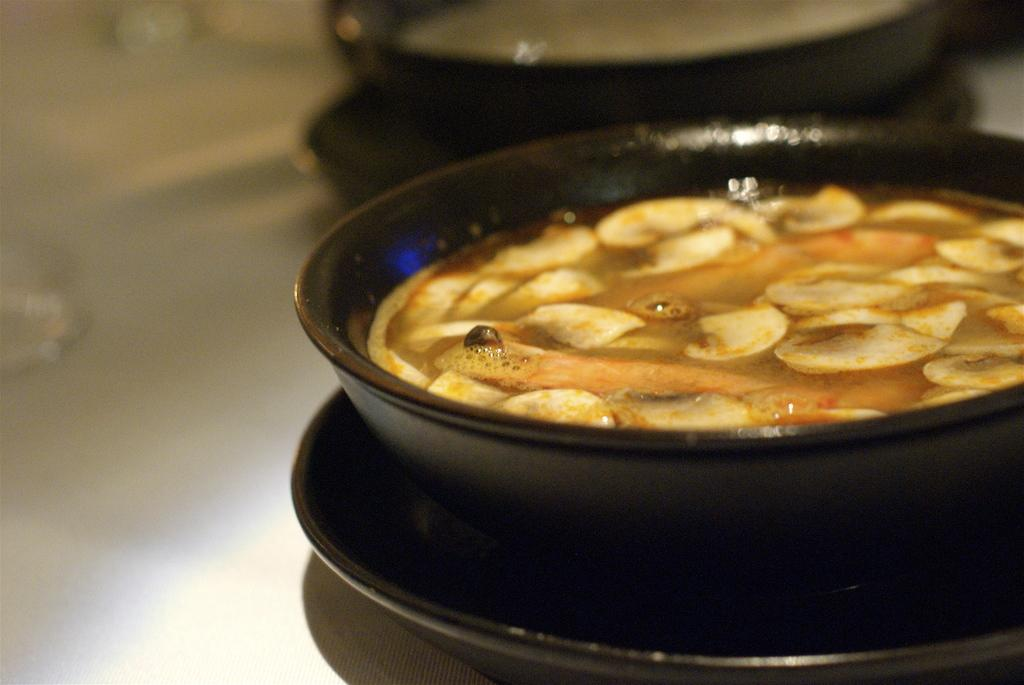What type of objects can be seen in the image? There are food items in the image. In what type of container are the food items placed? The food items are in a black color pan. Where is the group of birds nesting in the image? There are no birds or nests present in the image; it only features food items in a black color pan. 